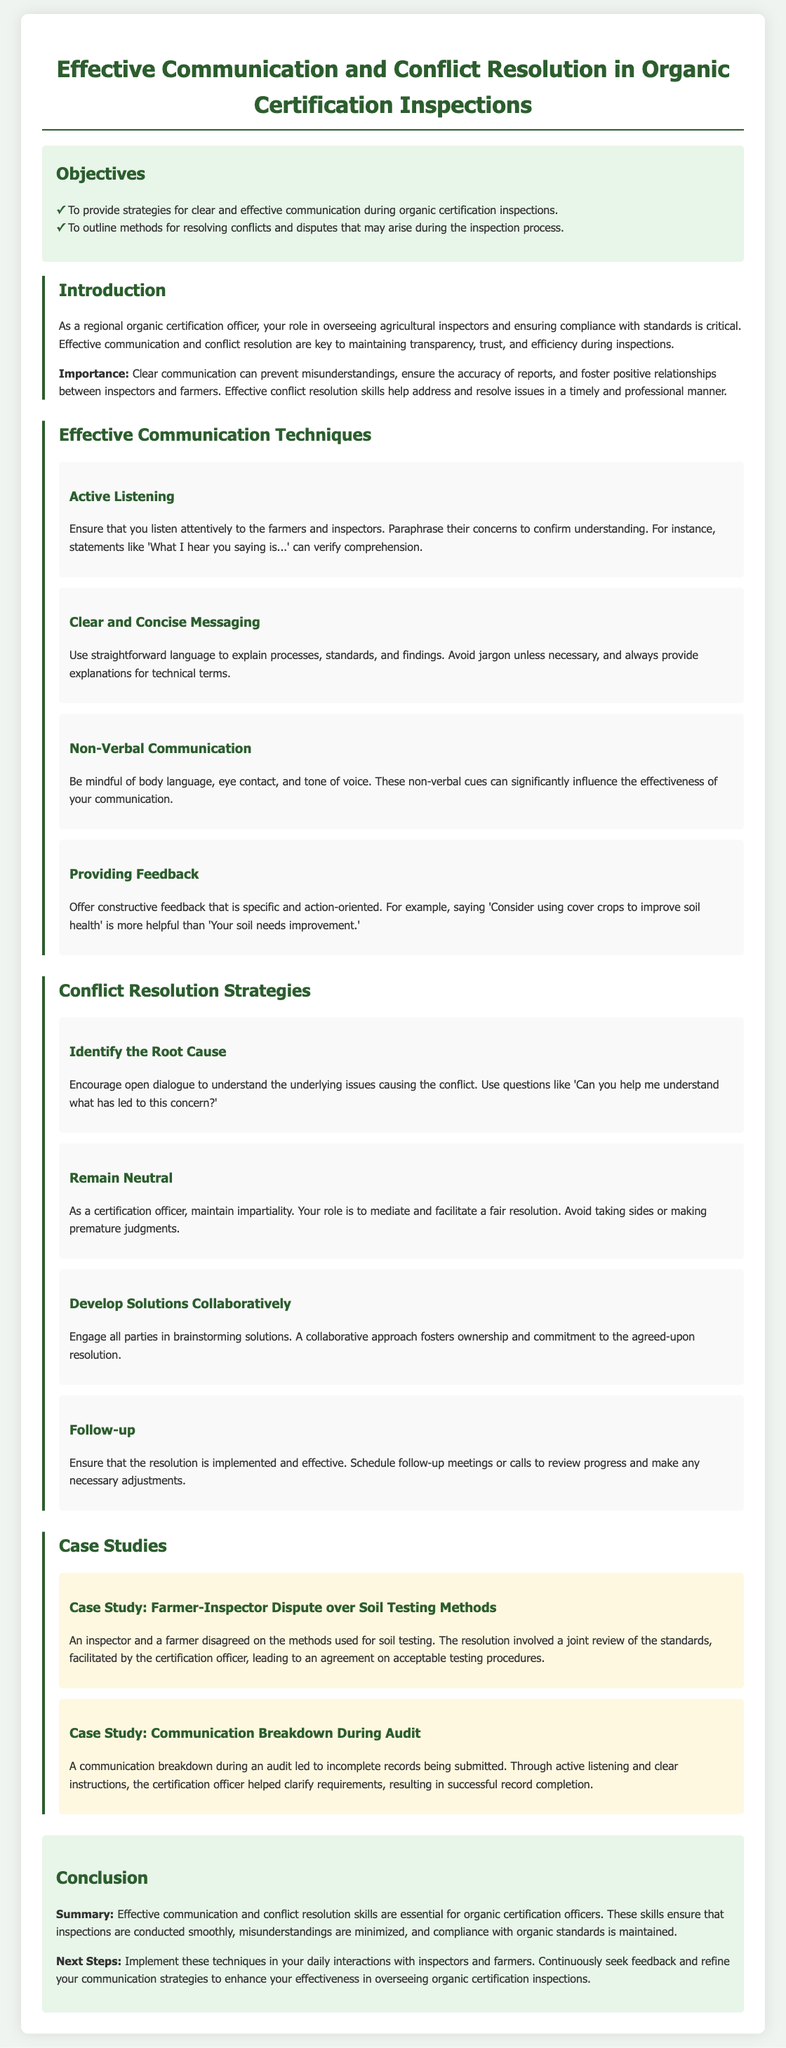what is the title of the lesson plan? The title appears at the top of the document, summarizing the focus of the content.
Answer: Effective Communication and Conflict Resolution in Organic Certification Inspections how many objectives are listed in the lesson plan? The number of objectives can be counted from the list presented in the objectives section.
Answer: 2 what is one effective communication technique mentioned? The document lists several techniques, and the answer can be found in the Effective Communication Techniques section.
Answer: Active Listening what should a certification officer do to resolve conflicts? The strategies for conflict resolution are outlined, and this can be directly referenced.
Answer: Remain Neutral what is an example of a case study mentioned in the document? Case studies are provided as examples in a specific section, and one can be quoted directly.
Answer: Farmer-Inspector Dispute over Soil Testing Methods what is the importance of effective communication according to the introduction? The introduction section explains the significance of communication in inspections.
Answer: Prevent misunderstandings what is a recommended follow-up action after resolving a conflict? The Conflict Resolution Strategies section provides a particular action to take post-resolution.
Answer: Follow-up what color is used for the background of the document? The background color of the document can be identified from the styling section.
Answer: #f0f4f0 what is the last section of the lesson plan called? The structure of the document has defined sections, with the last one specifically labeled.
Answer: Conclusion 